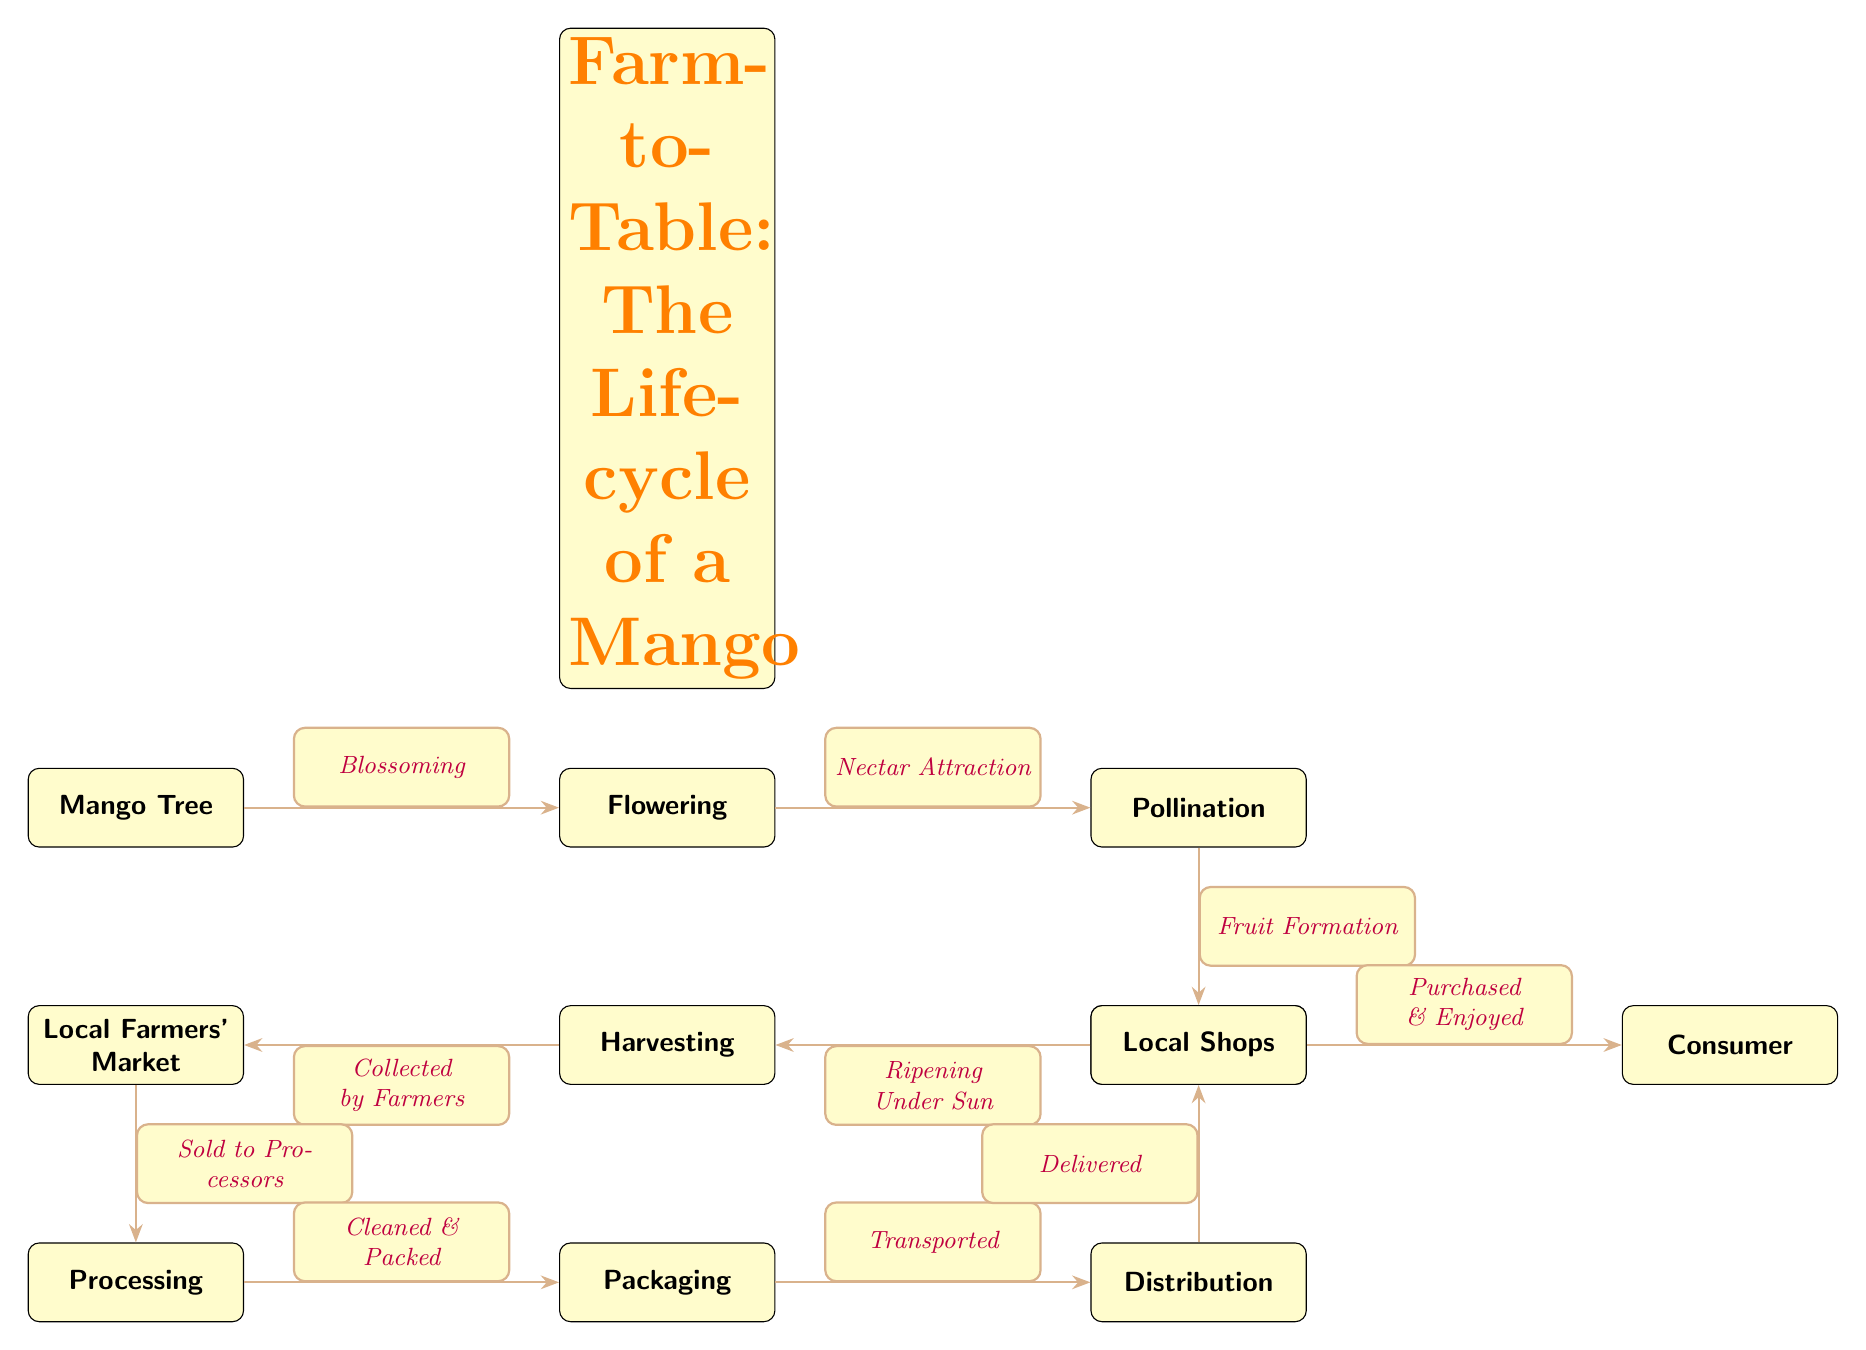What is the first step in the lifecycle of a mango? The diagram starts with the "Mango Tree" as the first node, indicating the first step in this lifecycle.
Answer: Mango Tree How many nodes are there in total? Counting each distinct node in the diagram shows that there are 11 nodes connected in the lifecycle of the mango from beginning to end.
Answer: 11 What happens after pollination? The flow from "Pollination" leads directly to "Fruit Formation," indicating the progression from pollination to the next stage.
Answer: Fruit Formation Which step involves local farmers? The diagram connects "Harvesting" with "Local Farmers' Market," showing that this step involves local farmers selling their produce.
Answer: Local Farmers' Market What is the last step experienced by a consumer? Following the flow from "Local Shops," the final step for the consumer is "Purchased & Enjoyed," marking the end of the lifecycle.
Answer: Purchased & Enjoyed What step follows the "Processing" node? After "Processing," the next step connected is "Packaging," indicating that packaging comes immediately after processing.
Answer: Packaging How is the mango transported after packaging? The diagram states that "Transported" occurs directly after "Packaging," which means transportation follows this step in the lifecycle.
Answer: Transported What occurs prior to harvesting? The stage before "Harvesting" is "Ripening Under Sun," showing a clear order of operations leading to the harvesting of the mango.
Answer: Ripening Under Sun What is the relationship between "Flowering" and "Pollination"? The relationship is represented with the edge labeled "Nectar Attraction," showcasing how flowering is essential for attracting pollinators.
Answer: Nectar Attraction 